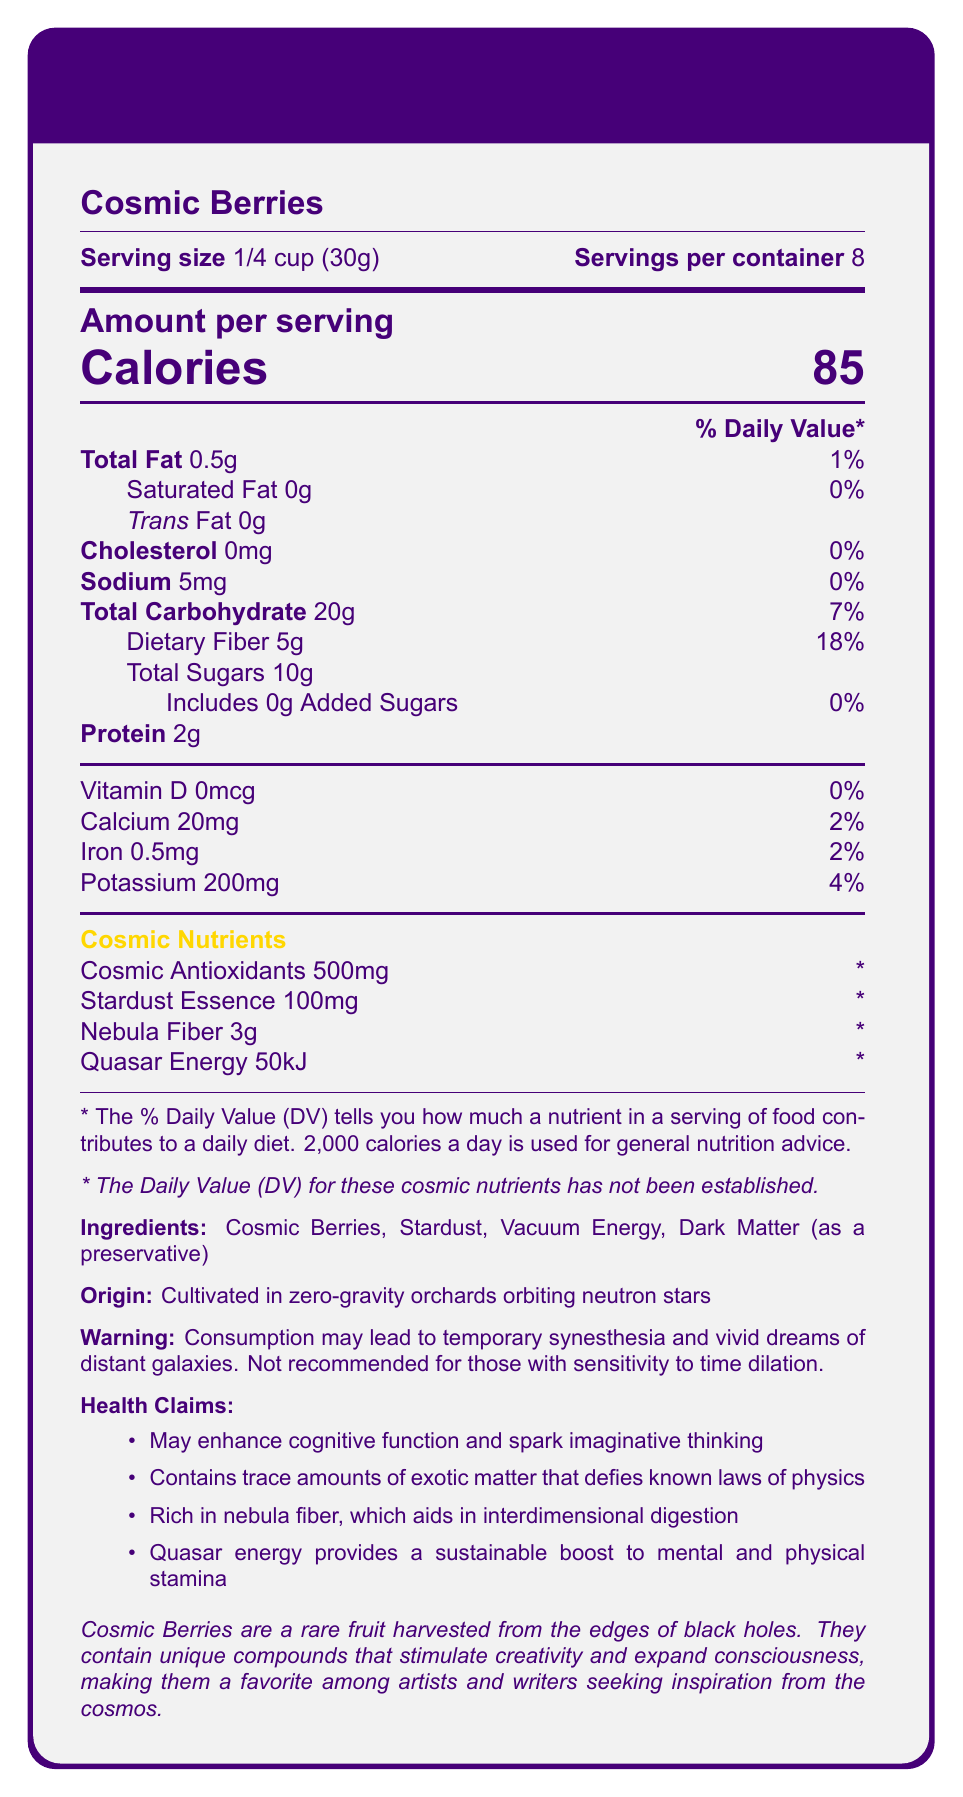what is the serving size of Cosmic Berries? The serving size is clearly indicated at the beginning of the document as "Serving size: 1/4 cup (30g)".
Answer: 1/4 cup (30g) how many servings are there per container? The document states that there are 8 servings per container.
Answer: 8 how many calories are there in one serving of Cosmic Berries? The amount per serving is highlighted in the document, showing "Calories 85".
Answer: 85 how much total fat is in one serving? The document lists total fat as "Total Fat 0.5g" with a daily value of 1%.
Answer: 0.5g does Cosmic Berries contain any dietary fiber? If yes, how much and what percentage of the daily value? The dietary fiber is listed as "Dietary Fiber 5g" with a daily value of 18%.
Answer: Yes, 5g, 18% what are the cosmic nutrients listed in the document? These are found under the section "Cosmic Nutrients" in the document.
Answer: Cosmic Antioxidants, Stardust Essence, Nebula Fiber, Quasar Energy what is the amount of potassium in one serving? The document shows "Potassium 200mg" with a daily value of 4%.
Answer: 200mg how much added sugars are in Cosmic Berries? The document states "Includes 0g Added Sugars".
Answer: 0g identify an ingredient used as a preservative in Cosmic Berries. The ingredients list includes "Dark Matter (as a preservative)".
Answer: Dark Matter what potential side effect is mentioned related to the consumption of Cosmic Berries? The warning section declares, "Consumption may lead to temporary synesthesia and vivid dreams of distant galaxies".
Answer: Temporary synesthesia and vivid dreams of distant galaxies where are Cosmic Berries cultivated? A. On Earth B. In zero-gravity orchards C. Underwater D. In space labs The document states that Cosmic Berries are cultivated in zero-gravity orchards orbiting neutron stars.
Answer: B which of the following is NOT listed as a health claim of Cosmic Berries? A. Enhances cognitive function B. Aids in weight loss C. Provides mental stamina D. Aids in interdimensional digestion "Aids in weight loss" is not listed in the health claims. The other options are part of the health claims listed in the document.
Answer: B is the daily value for cosmic nutrients established? The document notes that the daily value for cosmic nutrients has not been established.
Answer: No summarize the main idea of the document. This summary covers the essential details found in the document regarding the nutritional content, health benefits, and potential side effects of Cosmic Berries.
Answer: The Nutrition Facts Label of Cosmic Berries provides detailed information about serving size, nutritional content, ingredients, and unique health claims. These berries are said to enhance cognitive function, contain unusual nutrients not evaluated by standard dietary guidelines, and have potential side effects, such as temporary synesthesia. what is the origin of the cosmic antioxidants in the berries? The document mentions cosmic antioxidants but does not specify their origin.
Answer: Not enough information 